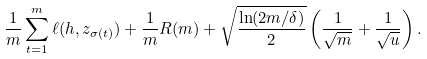Convert formula to latex. <formula><loc_0><loc_0><loc_500><loc_500>\frac { 1 } { m } \sum _ { t = 1 } ^ { m } \ell ( h , z _ { \sigma ( t ) } ) + \frac { 1 } { m } R ( m ) + \sqrt { \frac { \ln ( 2 m / \delta ) } { 2 } } \left ( \frac { 1 } { \sqrt { m } } + \frac { 1 } { \sqrt { u } } \right ) .</formula> 